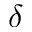<formula> <loc_0><loc_0><loc_500><loc_500>\delta</formula> 